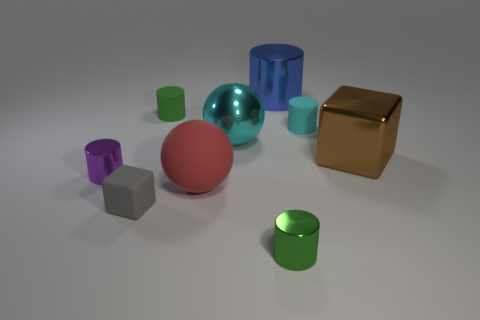What colors are represented by the objects in this scene? The objects in the image showcase a variety of colors including gray, purple, red, green, blue, transparent aqua, and a metallic gold. 